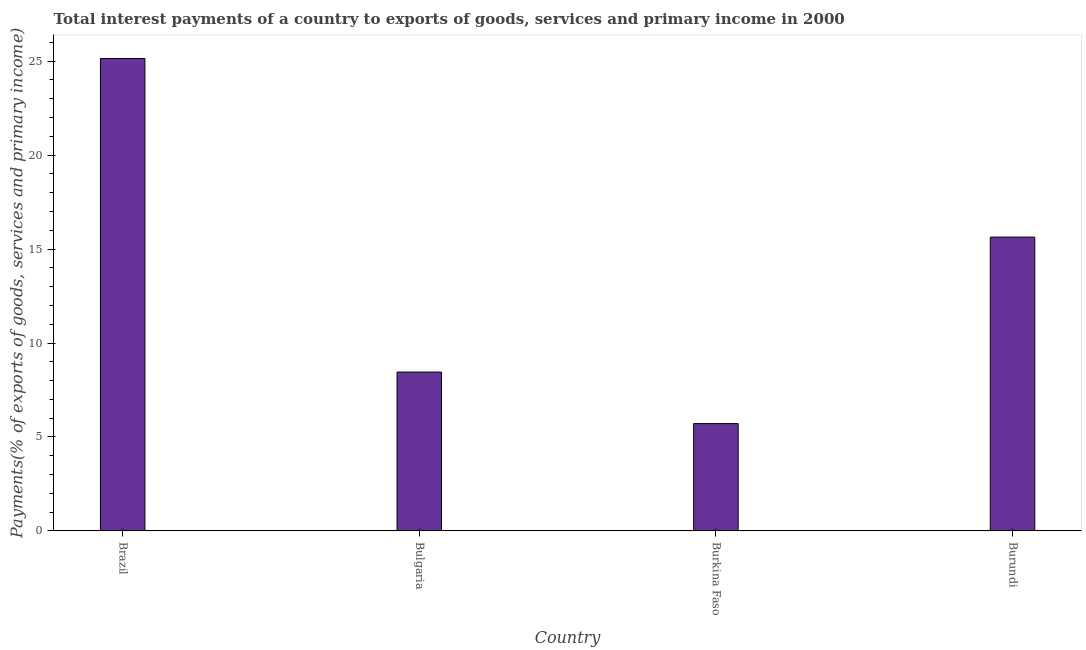Does the graph contain grids?
Your answer should be compact. No. What is the title of the graph?
Your answer should be very brief. Total interest payments of a country to exports of goods, services and primary income in 2000. What is the label or title of the Y-axis?
Your response must be concise. Payments(% of exports of goods, services and primary income). What is the total interest payments on external debt in Brazil?
Ensure brevity in your answer.  25.14. Across all countries, what is the maximum total interest payments on external debt?
Your answer should be very brief. 25.14. Across all countries, what is the minimum total interest payments on external debt?
Ensure brevity in your answer.  5.71. In which country was the total interest payments on external debt maximum?
Offer a very short reply. Brazil. In which country was the total interest payments on external debt minimum?
Ensure brevity in your answer.  Burkina Faso. What is the sum of the total interest payments on external debt?
Provide a succinct answer. 54.95. What is the difference between the total interest payments on external debt in Brazil and Burundi?
Provide a short and direct response. 9.51. What is the average total interest payments on external debt per country?
Ensure brevity in your answer.  13.74. What is the median total interest payments on external debt?
Make the answer very short. 12.05. In how many countries, is the total interest payments on external debt greater than 9 %?
Give a very brief answer. 2. What is the ratio of the total interest payments on external debt in Brazil to that in Burkina Faso?
Ensure brevity in your answer.  4.4. What is the difference between the highest and the second highest total interest payments on external debt?
Keep it short and to the point. 9.51. Is the sum of the total interest payments on external debt in Burkina Faso and Burundi greater than the maximum total interest payments on external debt across all countries?
Your response must be concise. No. What is the difference between the highest and the lowest total interest payments on external debt?
Offer a very short reply. 19.43. In how many countries, is the total interest payments on external debt greater than the average total interest payments on external debt taken over all countries?
Your response must be concise. 2. Are all the bars in the graph horizontal?
Ensure brevity in your answer.  No. How many countries are there in the graph?
Your response must be concise. 4. What is the difference between two consecutive major ticks on the Y-axis?
Make the answer very short. 5. What is the Payments(% of exports of goods, services and primary income) in Brazil?
Keep it short and to the point. 25.14. What is the Payments(% of exports of goods, services and primary income) of Bulgaria?
Ensure brevity in your answer.  8.45. What is the Payments(% of exports of goods, services and primary income) in Burkina Faso?
Provide a succinct answer. 5.71. What is the Payments(% of exports of goods, services and primary income) of Burundi?
Offer a terse response. 15.64. What is the difference between the Payments(% of exports of goods, services and primary income) in Brazil and Bulgaria?
Make the answer very short. 16.69. What is the difference between the Payments(% of exports of goods, services and primary income) in Brazil and Burkina Faso?
Provide a succinct answer. 19.43. What is the difference between the Payments(% of exports of goods, services and primary income) in Brazil and Burundi?
Your response must be concise. 9.51. What is the difference between the Payments(% of exports of goods, services and primary income) in Bulgaria and Burkina Faso?
Offer a very short reply. 2.74. What is the difference between the Payments(% of exports of goods, services and primary income) in Bulgaria and Burundi?
Provide a succinct answer. -7.18. What is the difference between the Payments(% of exports of goods, services and primary income) in Burkina Faso and Burundi?
Ensure brevity in your answer.  -9.92. What is the ratio of the Payments(% of exports of goods, services and primary income) in Brazil to that in Bulgaria?
Ensure brevity in your answer.  2.97. What is the ratio of the Payments(% of exports of goods, services and primary income) in Brazil to that in Burkina Faso?
Offer a terse response. 4.4. What is the ratio of the Payments(% of exports of goods, services and primary income) in Brazil to that in Burundi?
Provide a succinct answer. 1.61. What is the ratio of the Payments(% of exports of goods, services and primary income) in Bulgaria to that in Burkina Faso?
Make the answer very short. 1.48. What is the ratio of the Payments(% of exports of goods, services and primary income) in Bulgaria to that in Burundi?
Provide a short and direct response. 0.54. What is the ratio of the Payments(% of exports of goods, services and primary income) in Burkina Faso to that in Burundi?
Give a very brief answer. 0.36. 